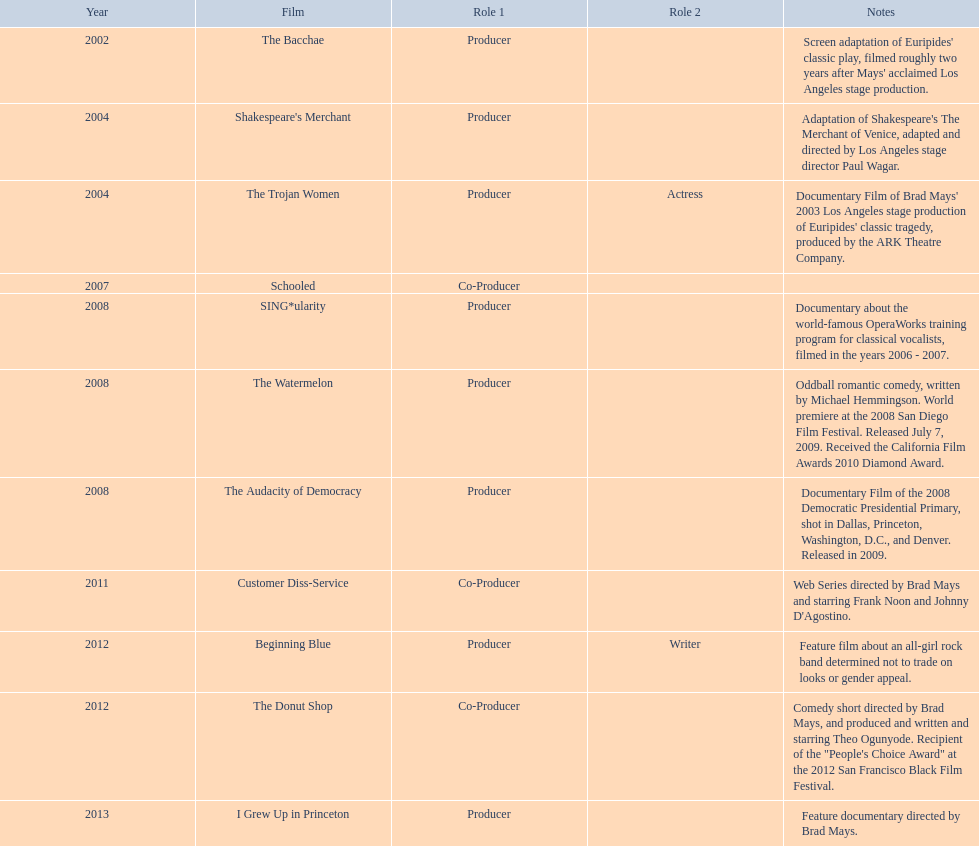How long was the film schooled out before beginning blue? 5 years. 